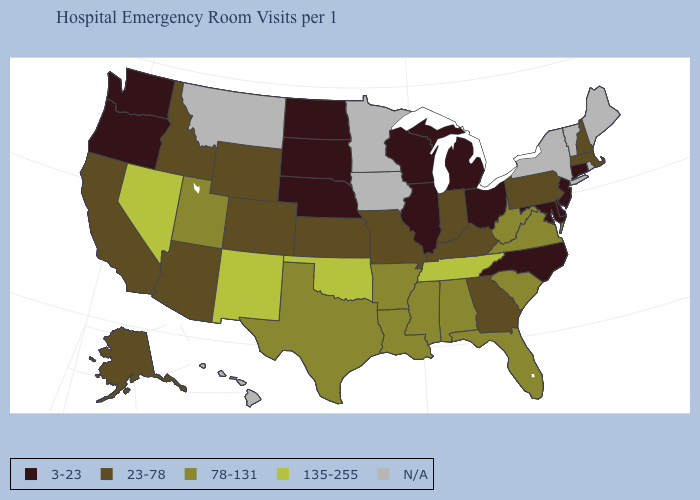What is the value of Maryland?
Give a very brief answer. 3-23. Among the states that border California , which have the lowest value?
Concise answer only. Oregon. What is the value of Oregon?
Quick response, please. 3-23. What is the value of Georgia?
Short answer required. 23-78. Which states have the highest value in the USA?
Write a very short answer. Nevada, New Mexico, Oklahoma, Tennessee. How many symbols are there in the legend?
Give a very brief answer. 5. What is the value of Illinois?
Quick response, please. 3-23. Does the map have missing data?
Answer briefly. Yes. Name the states that have a value in the range N/A?
Concise answer only. Hawaii, Iowa, Maine, Minnesota, Montana, New York, Rhode Island, Vermont. Is the legend a continuous bar?
Quick response, please. No. What is the value of Pennsylvania?
Concise answer only. 23-78. Does Utah have the lowest value in the West?
Write a very short answer. No. Among the states that border Arkansas , does Texas have the lowest value?
Give a very brief answer. No. Among the states that border Virginia , which have the highest value?
Be succinct. Tennessee. Does Alaska have the lowest value in the West?
Concise answer only. No. 